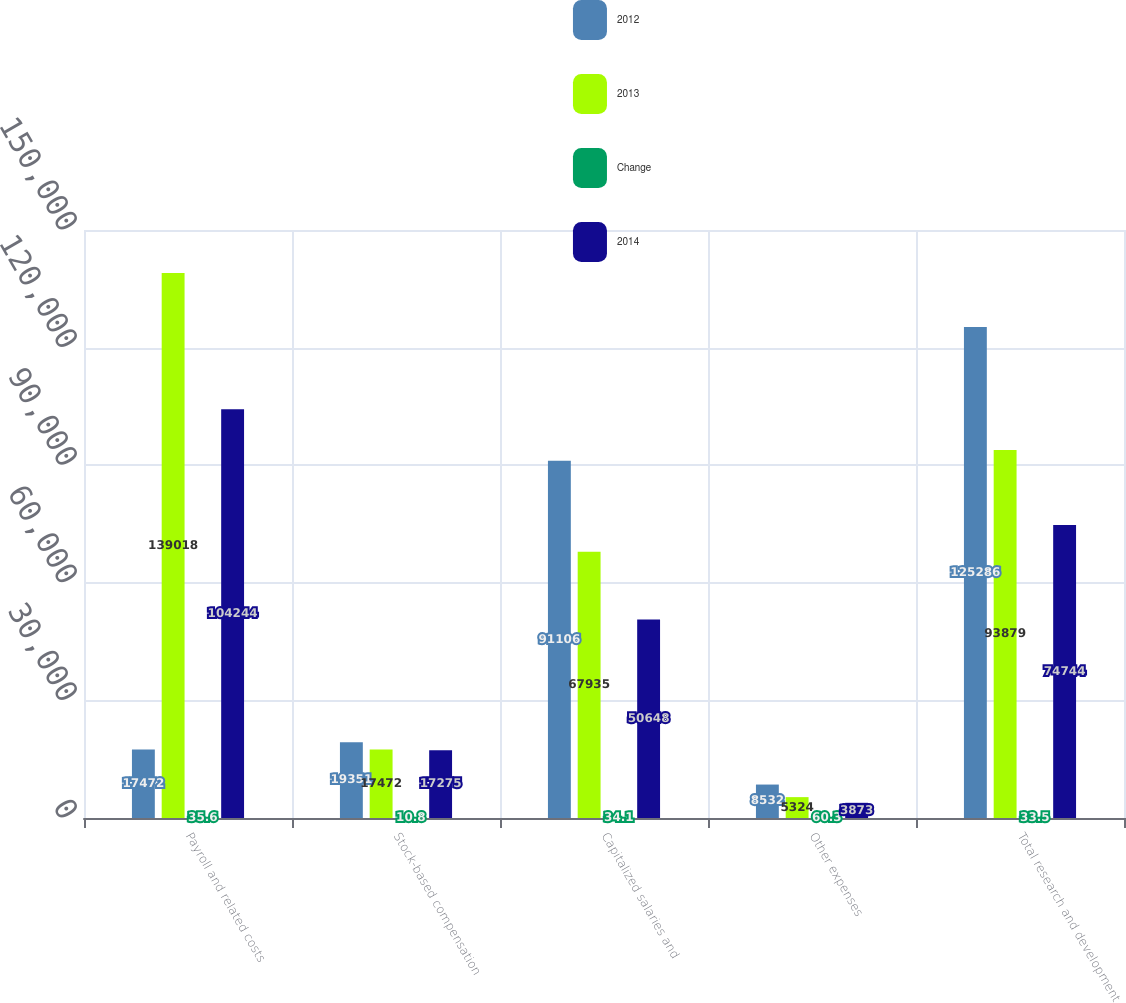Convert chart to OTSL. <chart><loc_0><loc_0><loc_500><loc_500><stacked_bar_chart><ecel><fcel>Payroll and related costs<fcel>Stock-based compensation<fcel>Capitalized salaries and<fcel>Other expenses<fcel>Total research and development<nl><fcel>2012<fcel>17472<fcel>19351<fcel>91106<fcel>8532<fcel>125286<nl><fcel>2013<fcel>139018<fcel>17472<fcel>67935<fcel>5324<fcel>93879<nl><fcel>Change<fcel>35.6<fcel>10.8<fcel>34.1<fcel>60.3<fcel>33.5<nl><fcel>2014<fcel>104244<fcel>17275<fcel>50648<fcel>3873<fcel>74744<nl></chart> 